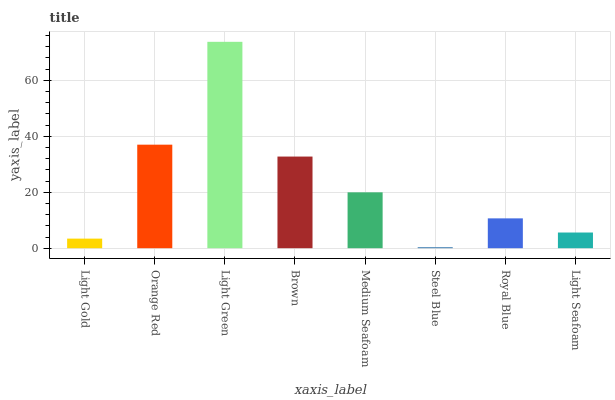Is Orange Red the minimum?
Answer yes or no. No. Is Orange Red the maximum?
Answer yes or no. No. Is Orange Red greater than Light Gold?
Answer yes or no. Yes. Is Light Gold less than Orange Red?
Answer yes or no. Yes. Is Light Gold greater than Orange Red?
Answer yes or no. No. Is Orange Red less than Light Gold?
Answer yes or no. No. Is Medium Seafoam the high median?
Answer yes or no. Yes. Is Royal Blue the low median?
Answer yes or no. Yes. Is Brown the high median?
Answer yes or no. No. Is Light Seafoam the low median?
Answer yes or no. No. 